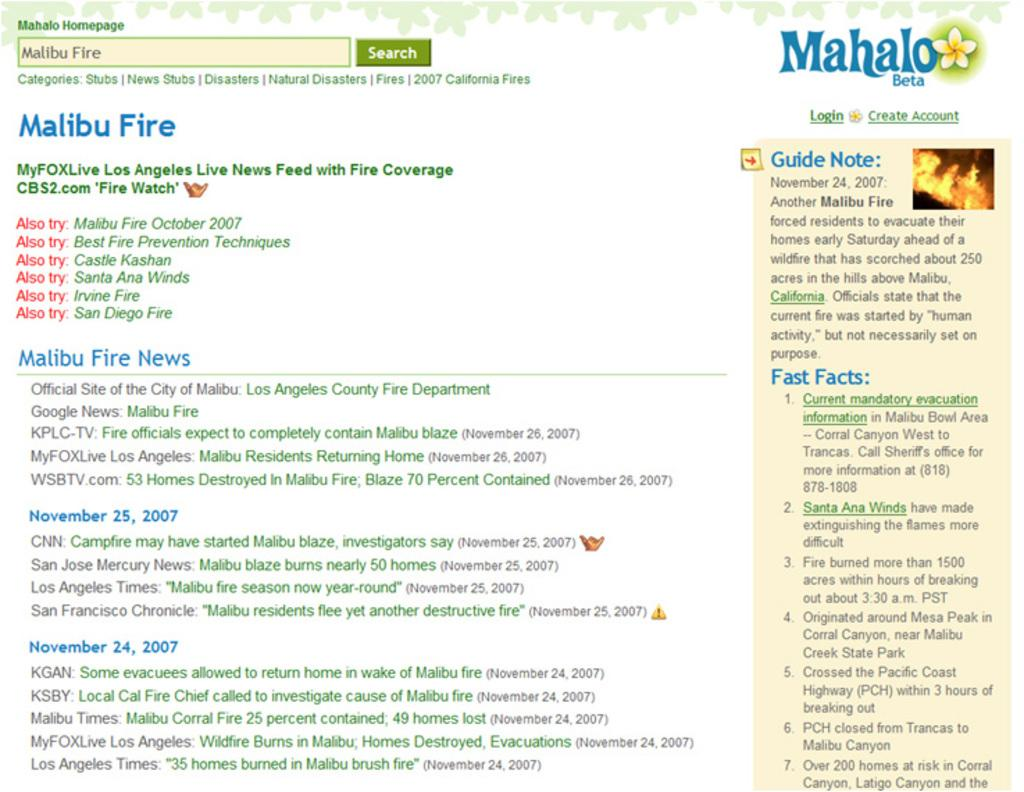What type of content is displayed in the image? The image consists of a poster or a web page. What can be found within the content of the image? There is text in the image. What is depicted on the right side of the image? There is a picture of fire on the right side of the image. What type of company is being advertised on the left side of the image? There is no company being advertised in the image, as it only contains text and a picture of fire. What type of gun is being taught in the image? There is no gun or teaching activity present in the image. 